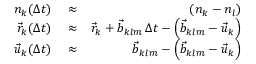<formula> <loc_0><loc_0><loc_500><loc_500>\begin{array} { r l r } { n _ { k } ( \Delta t ) } & \approx } & { \left ( n _ { k } - n _ { l } \right ) } \\ { \vec { r } _ { k } ( \Delta t ) } & \approx } & { \vec { r } _ { k } + \vec { b } _ { k l m } \, \Delta t - \left ( \vec { b } _ { k l m } - \vec { u } _ { k } \right ) } \\ { \vec { u } _ { k } ( \Delta t ) } & \approx } & { \vec { b } _ { k l m } - \left ( \vec { b } _ { k l m } - \vec { u } _ { k } \right ) } \end{array}</formula> 